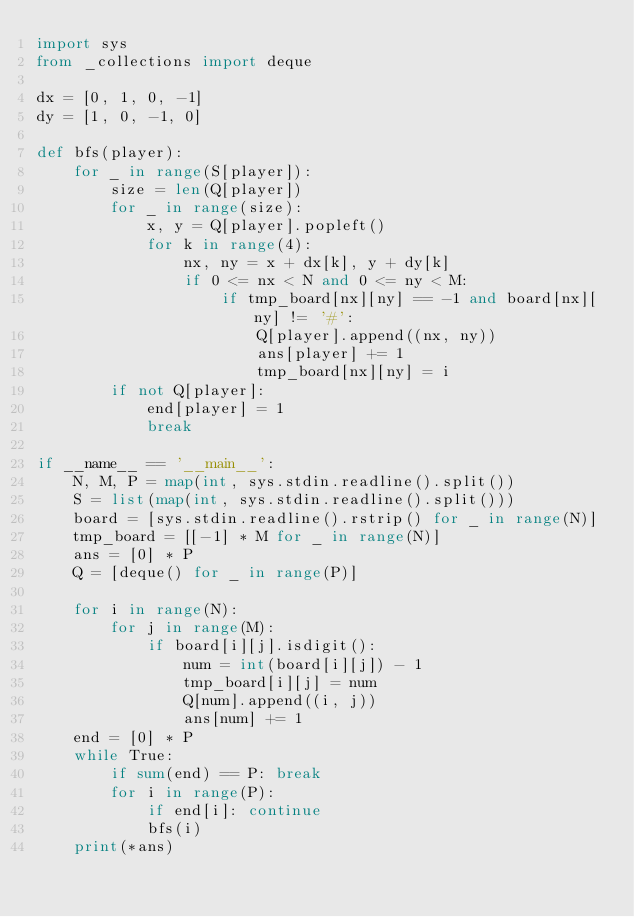<code> <loc_0><loc_0><loc_500><loc_500><_Python_>import sys
from _collections import deque

dx = [0, 1, 0, -1]
dy = [1, 0, -1, 0]

def bfs(player):
    for _ in range(S[player]):
        size = len(Q[player])
        for _ in range(size):
            x, y = Q[player].popleft()
            for k in range(4):
                nx, ny = x + dx[k], y + dy[k]
                if 0 <= nx < N and 0 <= ny < M:
                    if tmp_board[nx][ny] == -1 and board[nx][ny] != '#':
                        Q[player].append((nx, ny))
                        ans[player] += 1
                        tmp_board[nx][ny] = i
        if not Q[player]:
            end[player] = 1
            break

if __name__ == '__main__':
    N, M, P = map(int, sys.stdin.readline().split())
    S = list(map(int, sys.stdin.readline().split()))
    board = [sys.stdin.readline().rstrip() for _ in range(N)]
    tmp_board = [[-1] * M for _ in range(N)]
    ans = [0] * P
    Q = [deque() for _ in range(P)]

    for i in range(N):
        for j in range(M):
            if board[i][j].isdigit():
                num = int(board[i][j]) - 1
                tmp_board[i][j] = num
                Q[num].append((i, j))
                ans[num] += 1
    end = [0] * P
    while True:
        if sum(end) == P: break
        for i in range(P):
            if end[i]: continue
            bfs(i)
    print(*ans)</code> 